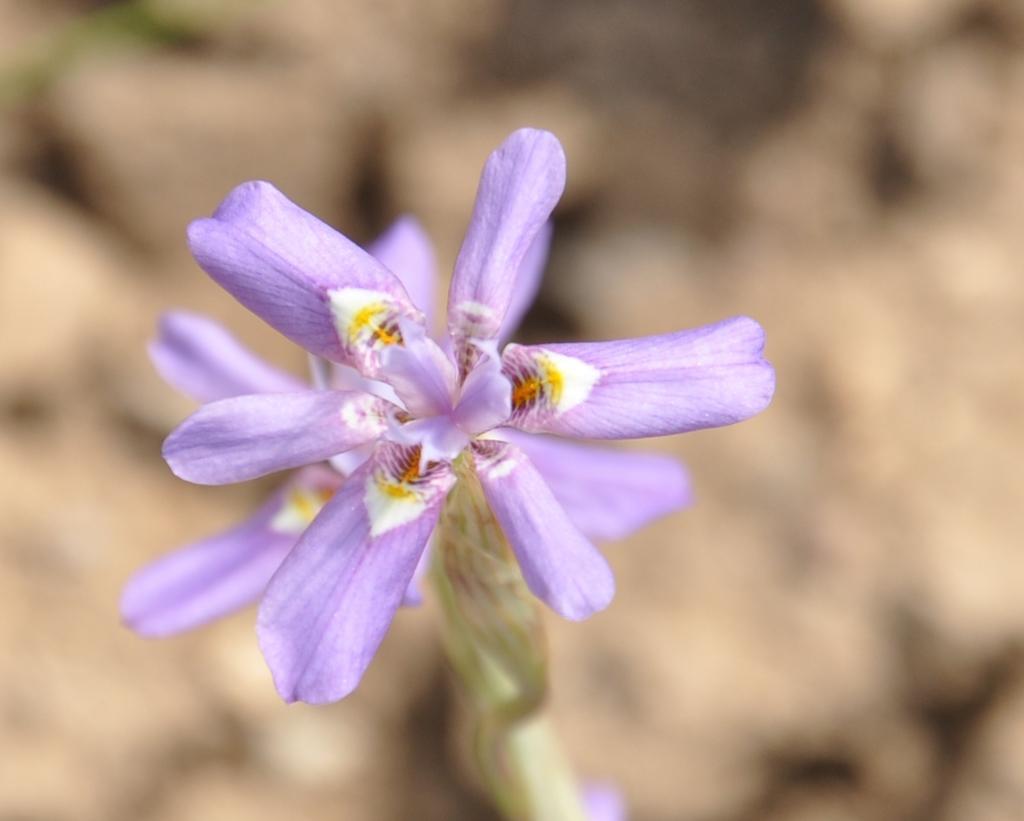Please provide a concise description of this image. In this image we can see some flowers. 